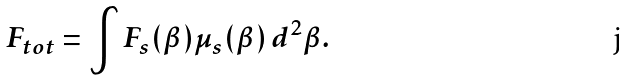<formula> <loc_0><loc_0><loc_500><loc_500>F _ { t o t } = \int F _ { s } ( \beta ) \mu _ { s } ( \beta ) \, d ^ { 2 } \beta .</formula> 